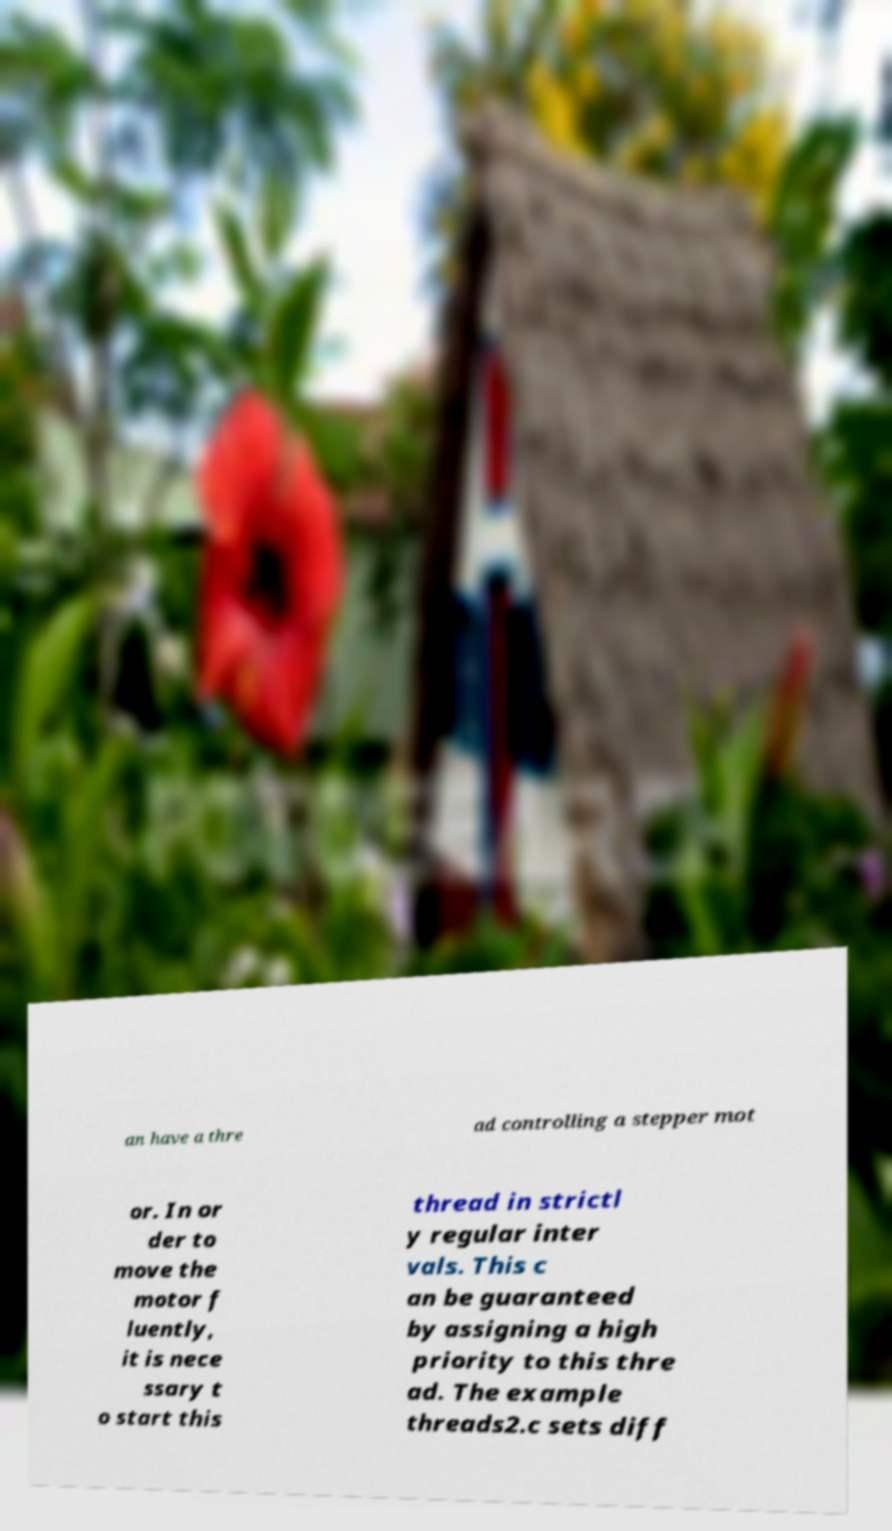I need the written content from this picture converted into text. Can you do that? an have a thre ad controlling a stepper mot or. In or der to move the motor f luently, it is nece ssary t o start this thread in strictl y regular inter vals. This c an be guaranteed by assigning a high priority to this thre ad. The example threads2.c sets diff 